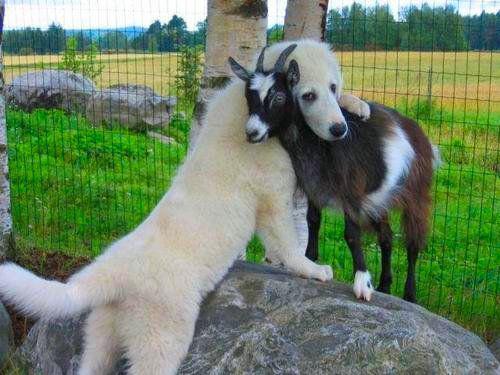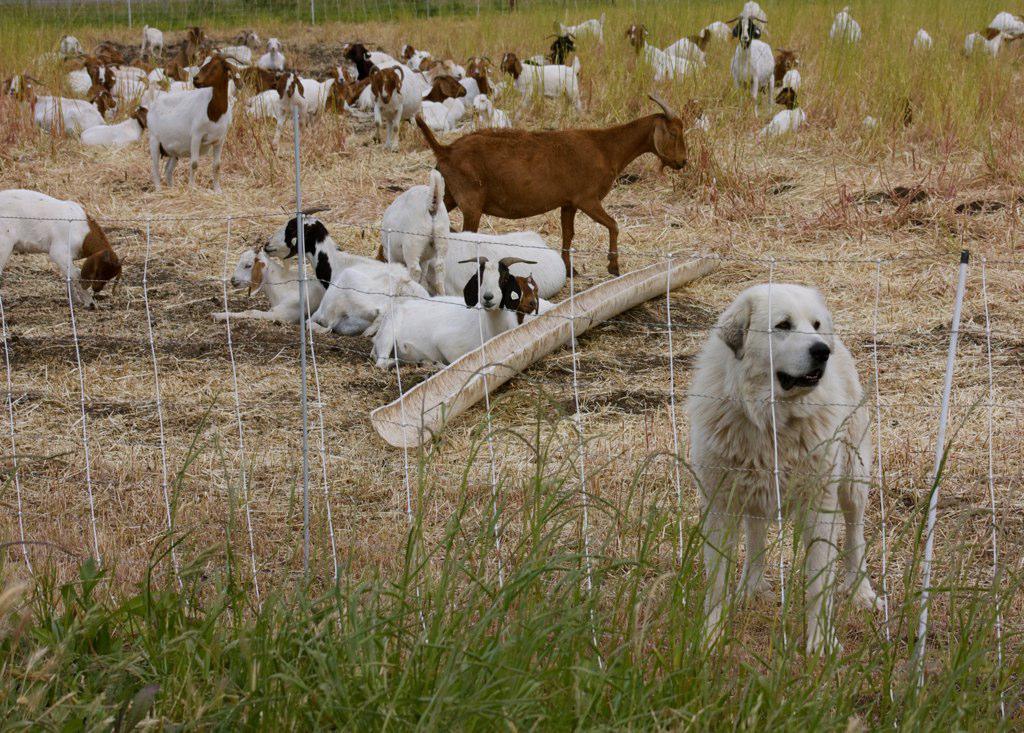The first image is the image on the left, the second image is the image on the right. For the images shown, is this caption "There is exactly one dog and one goat in the image on the left." true? Answer yes or no. Yes. 